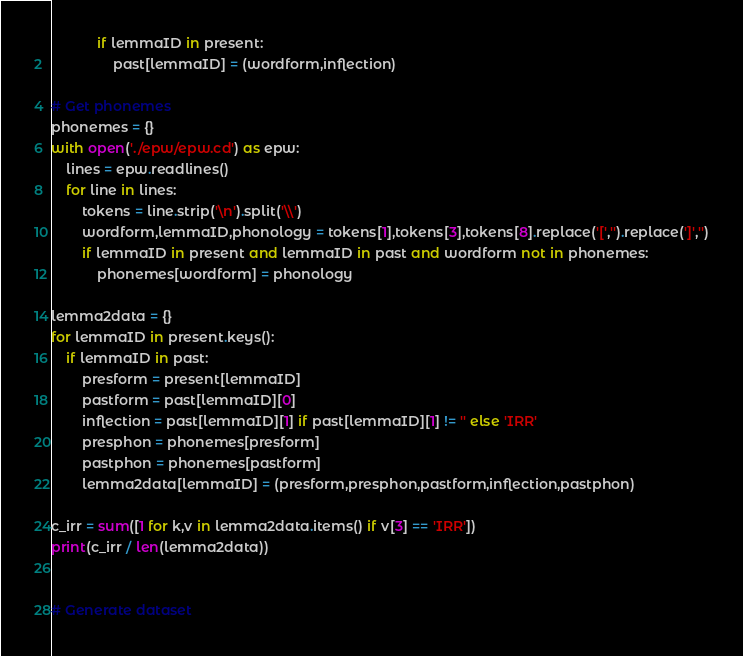<code> <loc_0><loc_0><loc_500><loc_500><_Python_>			if lemmaID in present:
				past[lemmaID] = (wordform,inflection)

# Get phonemes
phonemes = {}
with open('./epw/epw.cd') as epw:
	lines = epw.readlines()
	for line in lines:
		tokens = line.strip('\n').split('\\')
		wordform,lemmaID,phonology = tokens[1],tokens[3],tokens[8].replace('[','').replace(']','')
		if lemmaID in present and lemmaID in past and wordform not in phonemes:
			phonemes[wordform] = phonology

lemma2data = {}
for lemmaID in present.keys():
	if lemmaID in past:
		presform = present[lemmaID]
		pastform = past[lemmaID][0]
		inflection = past[lemmaID][1] if past[lemmaID][1] != '' else 'IRR'
		presphon = phonemes[presform]
		pastphon = phonemes[pastform]
		lemma2data[lemmaID] = (presform,presphon,pastform,inflection,pastphon)

c_irr = sum([1 for k,v in lemma2data.items() if v[3] == 'IRR'])
print(c_irr / len(lemma2data))


# Generate dataset


</code> 